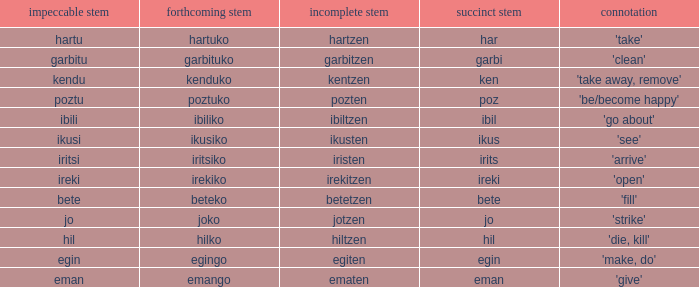Name the perfect stem for jo 1.0. 